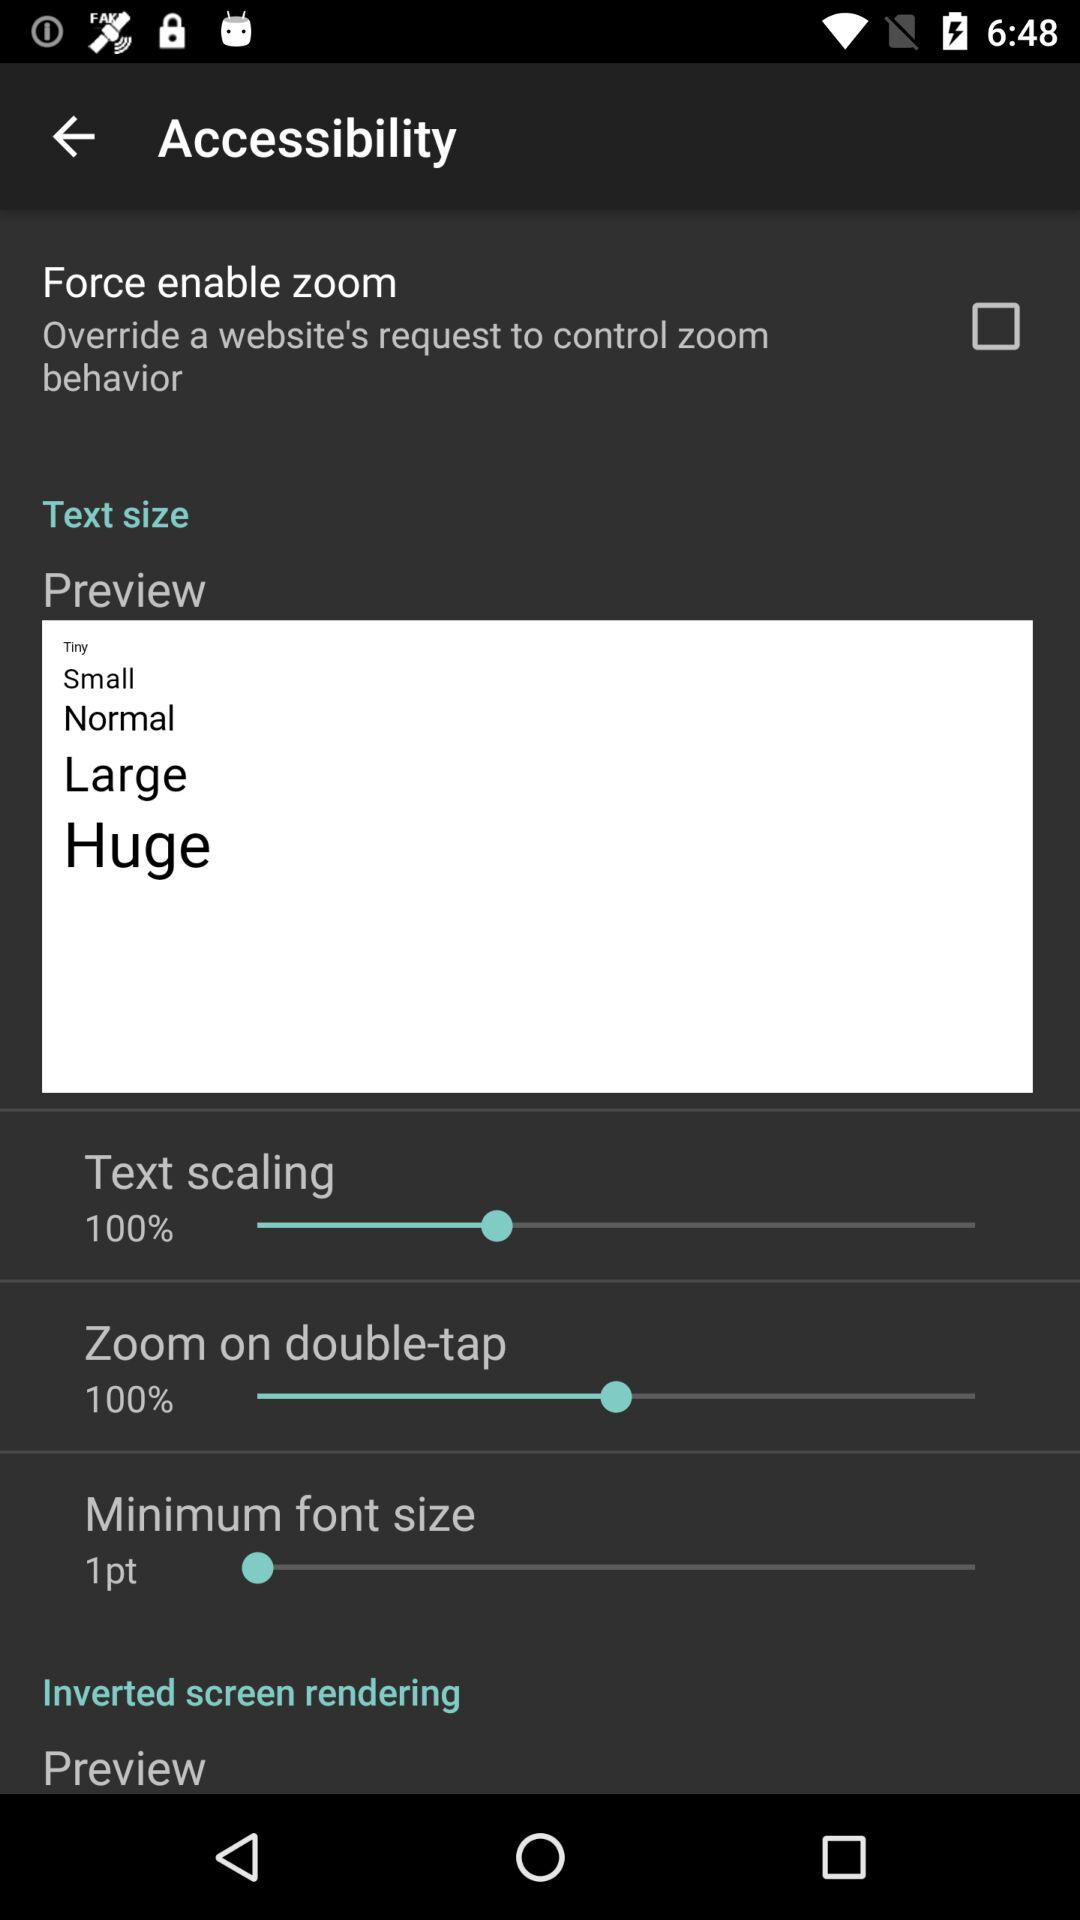What is the percentage of "Zoom on double-tap"? The percentage is 100. 